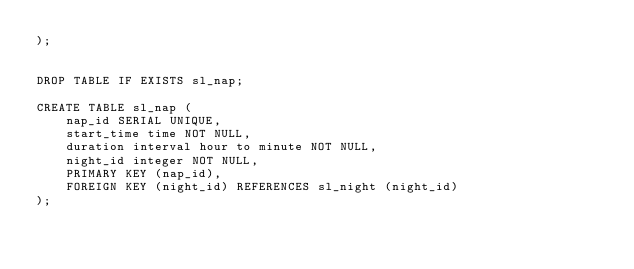<code> <loc_0><loc_0><loc_500><loc_500><_SQL_>);


DROP TABLE IF EXISTS sl_nap;

CREATE TABLE sl_nap (
    nap_id SERIAL UNIQUE, 
    start_time time NOT NULL,
    duration interval hour to minute NOT NULL,
    night_id integer NOT NULL,
    PRIMARY KEY (nap_id),
    FOREIGN KEY (night_id) REFERENCES sl_night (night_id)
);
</code> 